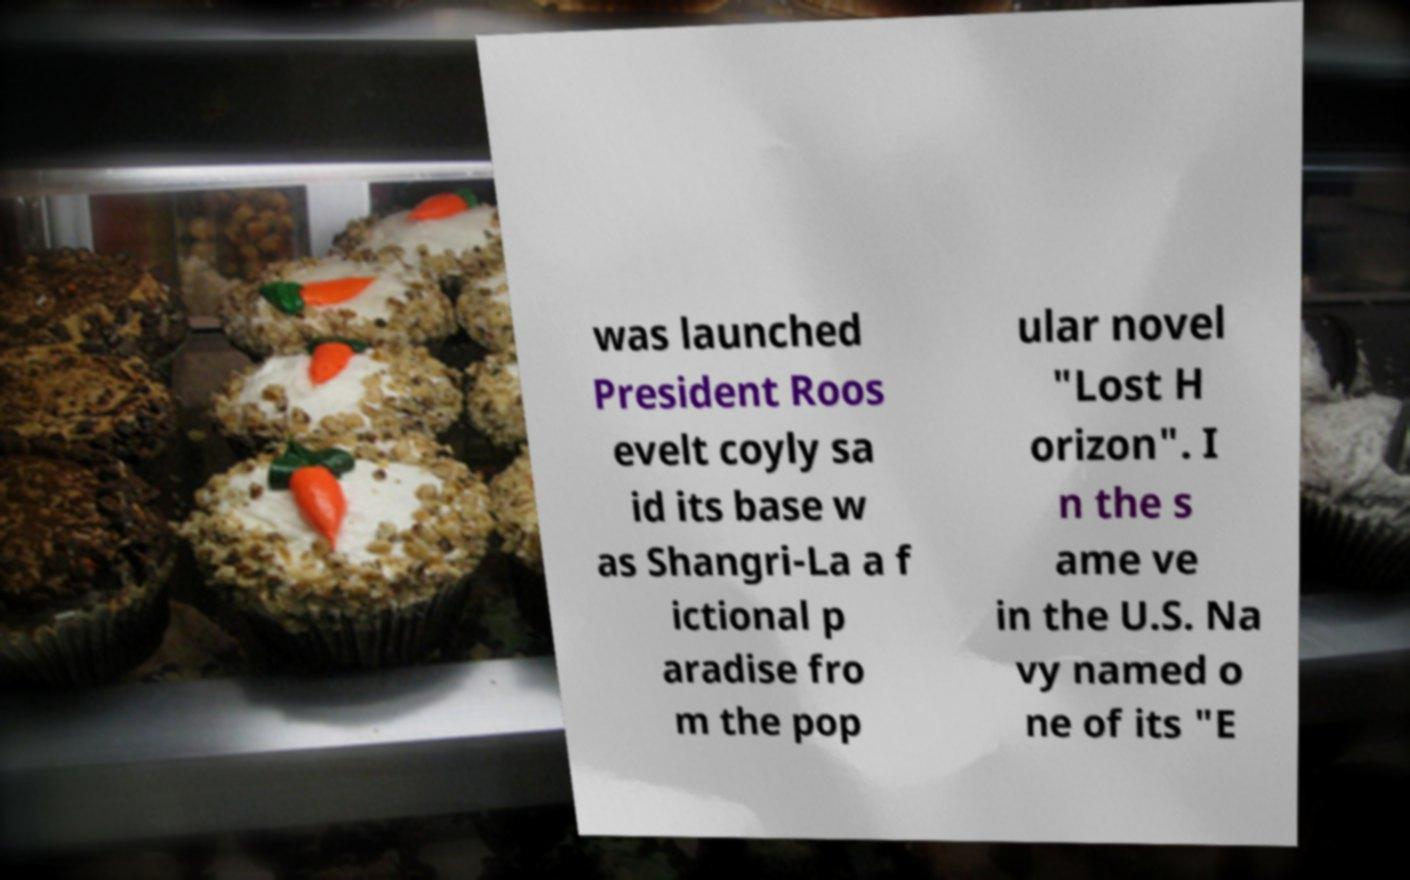Could you extract and type out the text from this image? was launched President Roos evelt coyly sa id its base w as Shangri-La a f ictional p aradise fro m the pop ular novel "Lost H orizon". I n the s ame ve in the U.S. Na vy named o ne of its "E 